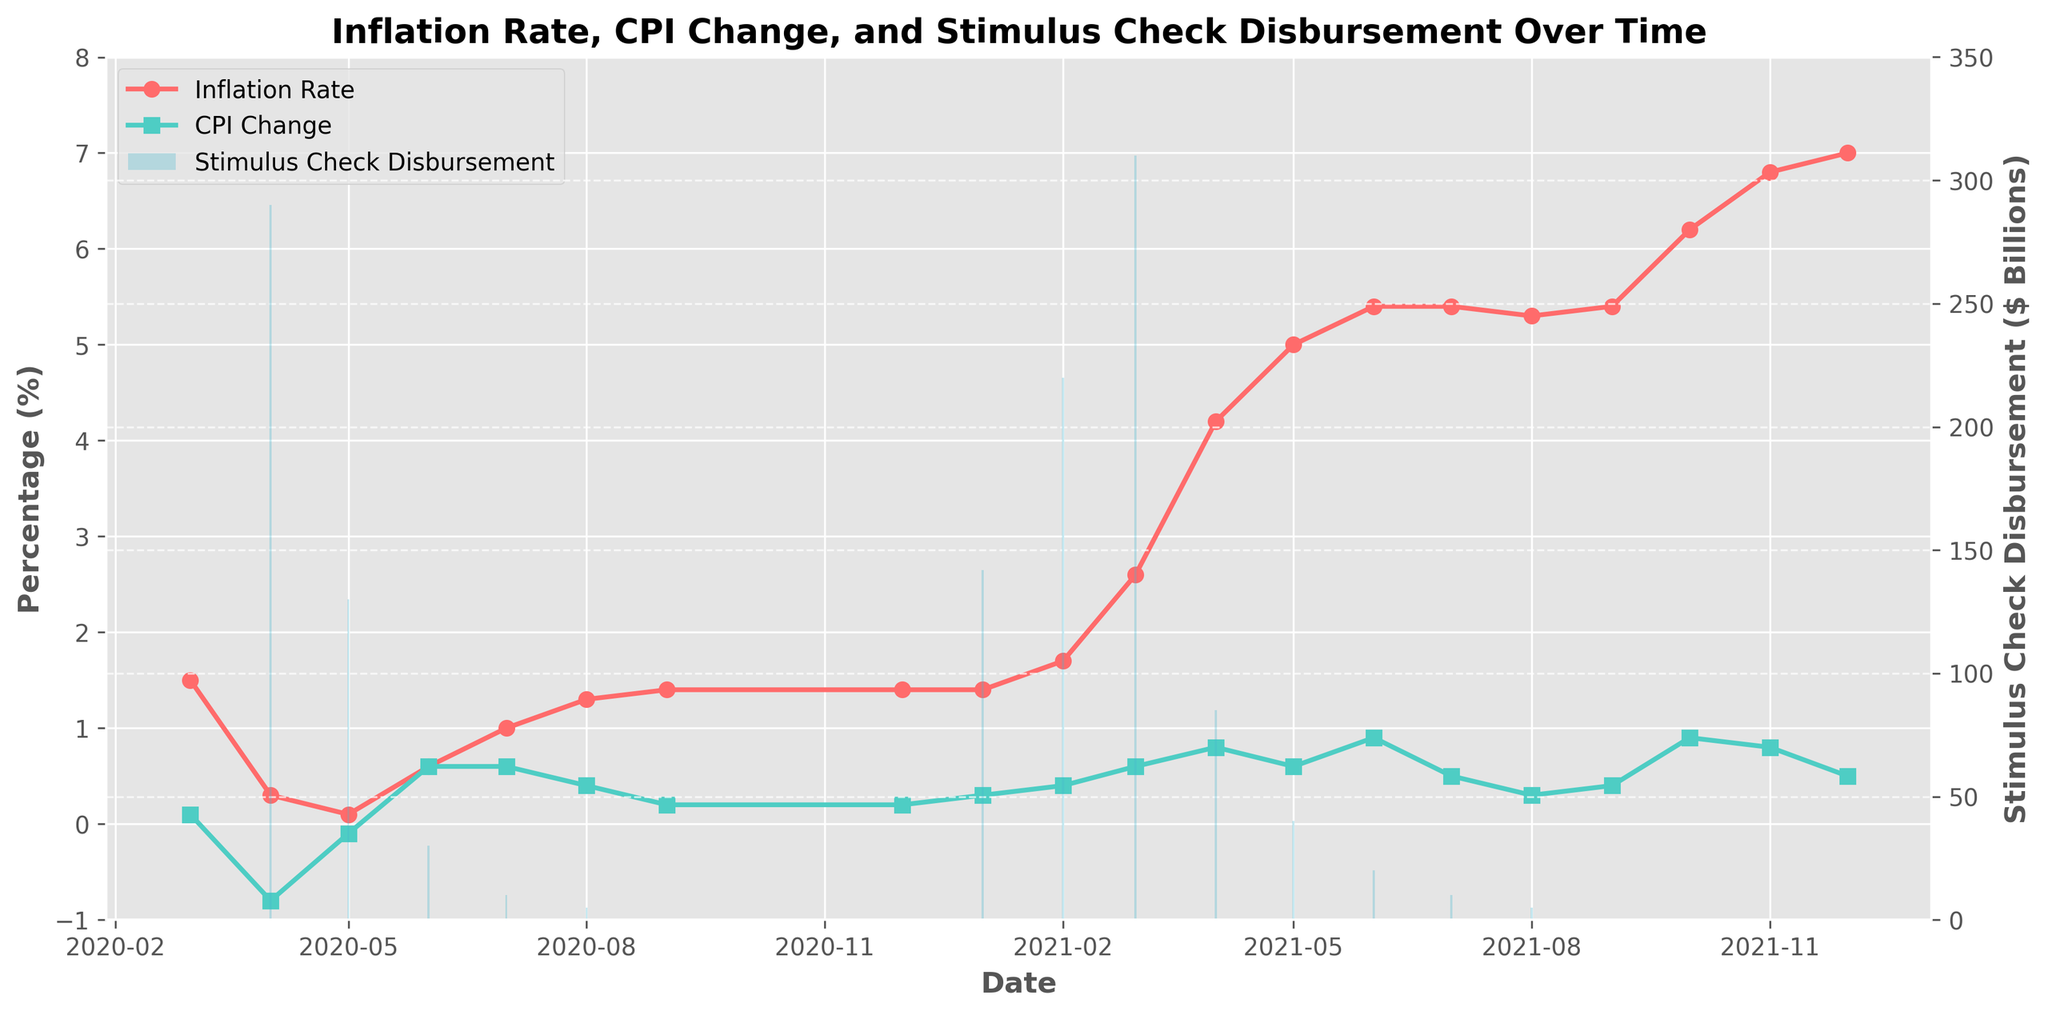What is the highest inflation rate recorded in the dataset? Hightest inflation rate refers to the peak value on the inflation rate line (red line). Scan through the line to find the highest point, which occurs in December 2021. The inflation rate peaks at 7.0%.
Answer: 7.0% What was the CPI change percentage in April 2020? To determine the CPI change percentage for a particular month, locate April 2020 on the x-axis and read the value of the green line representing CPI change. The value is -0.8%.
Answer: -0.8% In which month was the largest stimulus check disbursement made? Check all the bars in the plot and locate the tallest one to find the month with the largest disbursement. The tallest bar is in March 2021, representing a stimulus check disbursement of $310 billion.
Answer: March 2021 What is the overall change in the inflation rate from March 2020 to December 2021? Subtract the inflation rate in March 2020 (1.5%) from the rate in December 2021 (7.0%). The overall change is 7.0% - 1.5% = 5.5%.
Answer: 5.5% How does the CPI change compare before and after the largest stimulus check disbursement in March 2021? Identify the CPI change before March 2021, which is 0.4% (February 2021), and after March 2021, which is 0.8% (April 2021). The CPI change increased from 0.4% to 0.8%. Therefore, the CPI change doubled after the largest disbursement.
Answer: Doubled What is the trend of inflation rates over the period covered by the data? Observe the inflation rate (red line) from March 2020 to December 2021. Notice whether it is increasing, decreasing, or staying constant. The general trend is an increase in the inflation rate over time, peaking in December 2021.
Answer: Increasing Compare the CPI change and inflation rate in June 2021. Which is higher? Locate June 2021 on the x-axis and compare the values of the CPI change (green line) and inflation rate (red line). CPI change is 0.9%, and the inflation rate is 5.4%. The inflation rate is higher at 5.4%.
Answer: Inflation Rate Between which two consecutive months did the inflation rate increase the most? Compare the monthly increases in the inflation rate by checking the steepest upward slopes in the red line. The sharpest increase is between February 2021 (1.7%) and March 2021 (2.6%), a jump of 0.9%.
Answer: February 2021 and March 2021 